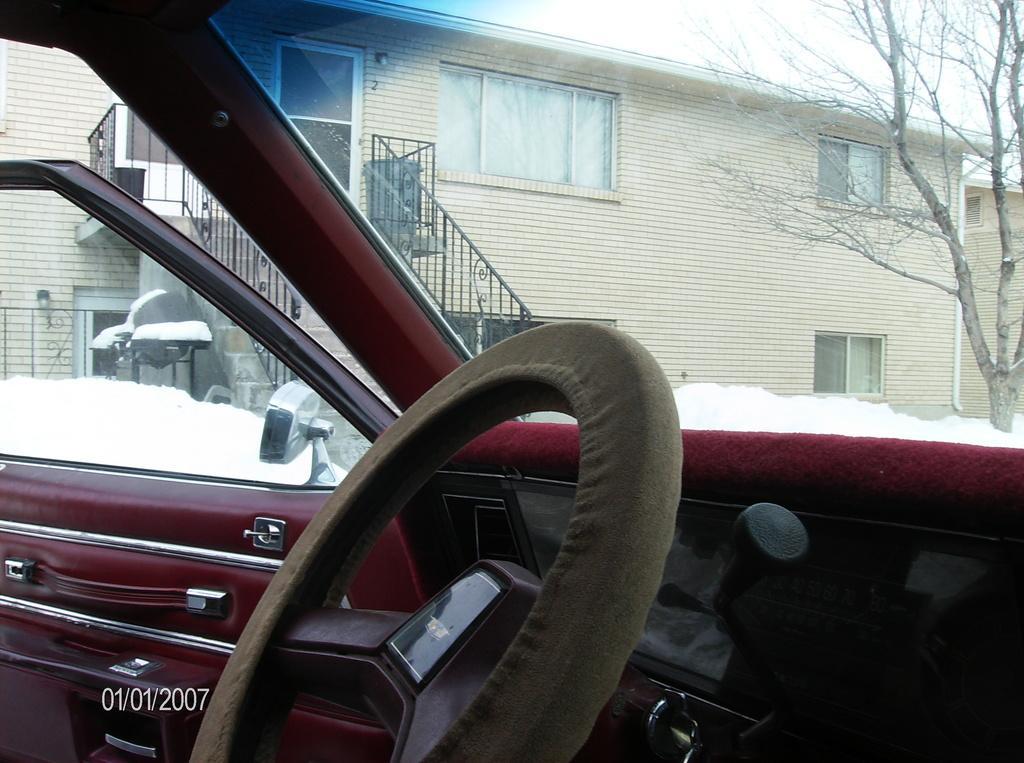How would you summarize this image in a sentence or two? In this picture I see the inside of a car in front and I see the steering and I see the watermark on the left bottom and in the background I see the houses, a tree and the snow. 